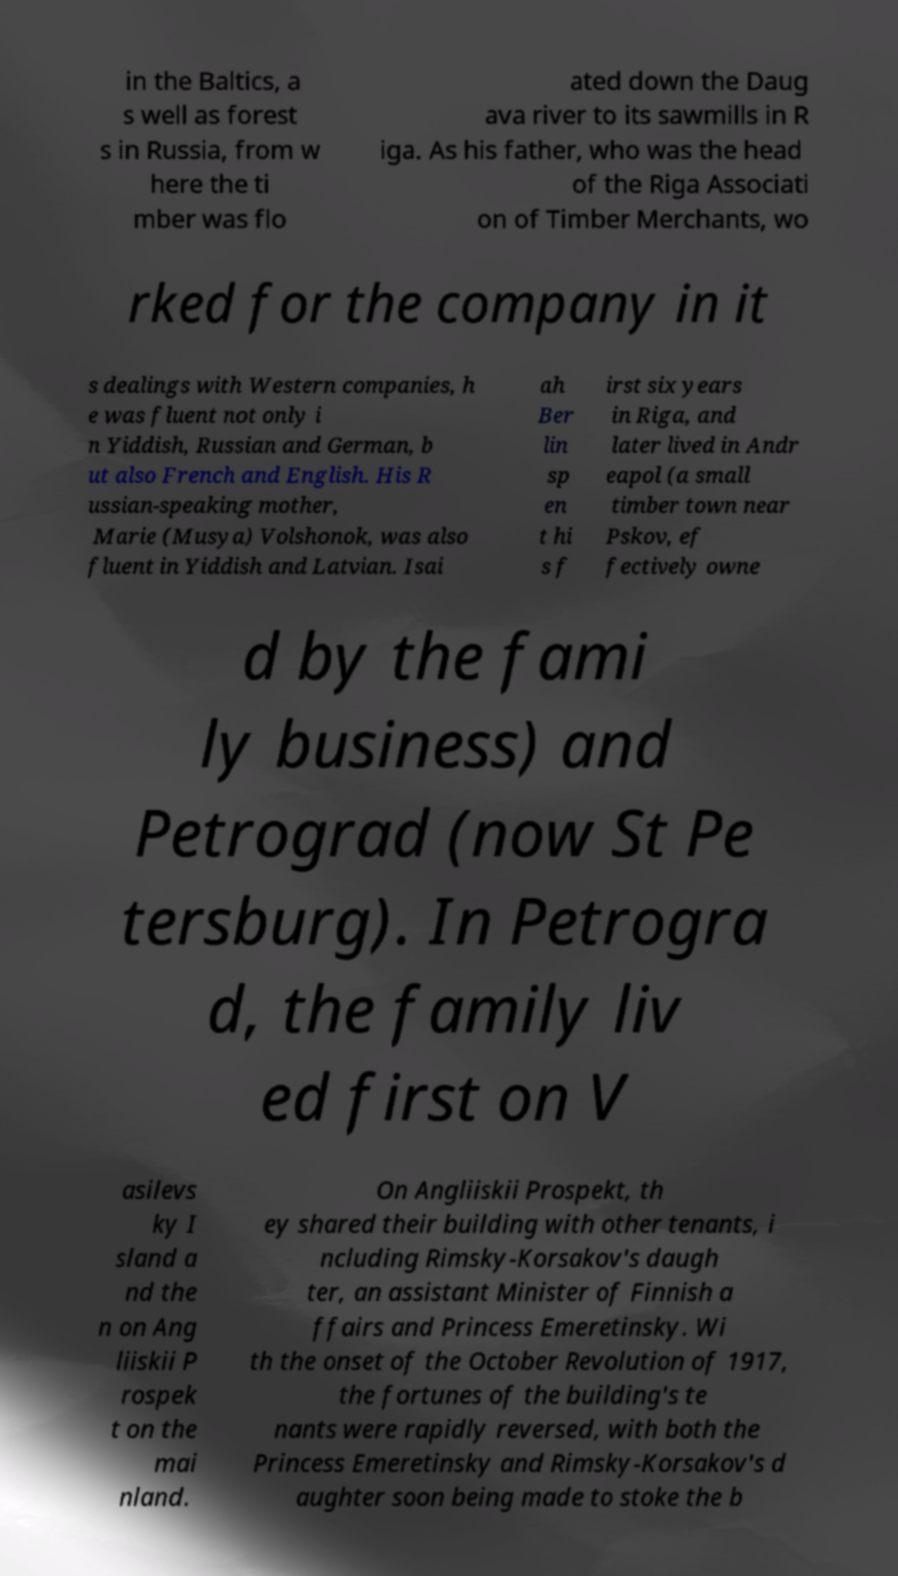Could you extract and type out the text from this image? in the Baltics, a s well as forest s in Russia, from w here the ti mber was flo ated down the Daug ava river to its sawmills in R iga. As his father, who was the head of the Riga Associati on of Timber Merchants, wo rked for the company in it s dealings with Western companies, h e was fluent not only i n Yiddish, Russian and German, b ut also French and English. His R ussian-speaking mother, Marie (Musya) Volshonok, was also fluent in Yiddish and Latvian. Isai ah Ber lin sp en t hi s f irst six years in Riga, and later lived in Andr eapol (a small timber town near Pskov, ef fectively owne d by the fami ly business) and Petrograd (now St Pe tersburg). In Petrogra d, the family liv ed first on V asilevs ky I sland a nd the n on Ang liiskii P rospek t on the mai nland. On Angliiskii Prospekt, th ey shared their building with other tenants, i ncluding Rimsky-Korsakov's daugh ter, an assistant Minister of Finnish a ffairs and Princess Emeretinsky. Wi th the onset of the October Revolution of 1917, the fortunes of the building's te nants were rapidly reversed, with both the Princess Emeretinsky and Rimsky-Korsakov's d aughter soon being made to stoke the b 